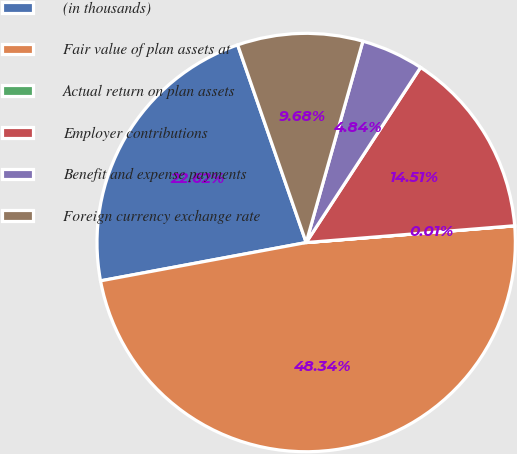Convert chart. <chart><loc_0><loc_0><loc_500><loc_500><pie_chart><fcel>(in thousands)<fcel>Fair value of plan assets at<fcel>Actual return on plan assets<fcel>Employer contributions<fcel>Benefit and expense payments<fcel>Foreign currency exchange rate<nl><fcel>22.62%<fcel>48.34%<fcel>0.01%<fcel>14.51%<fcel>4.84%<fcel>9.68%<nl></chart> 